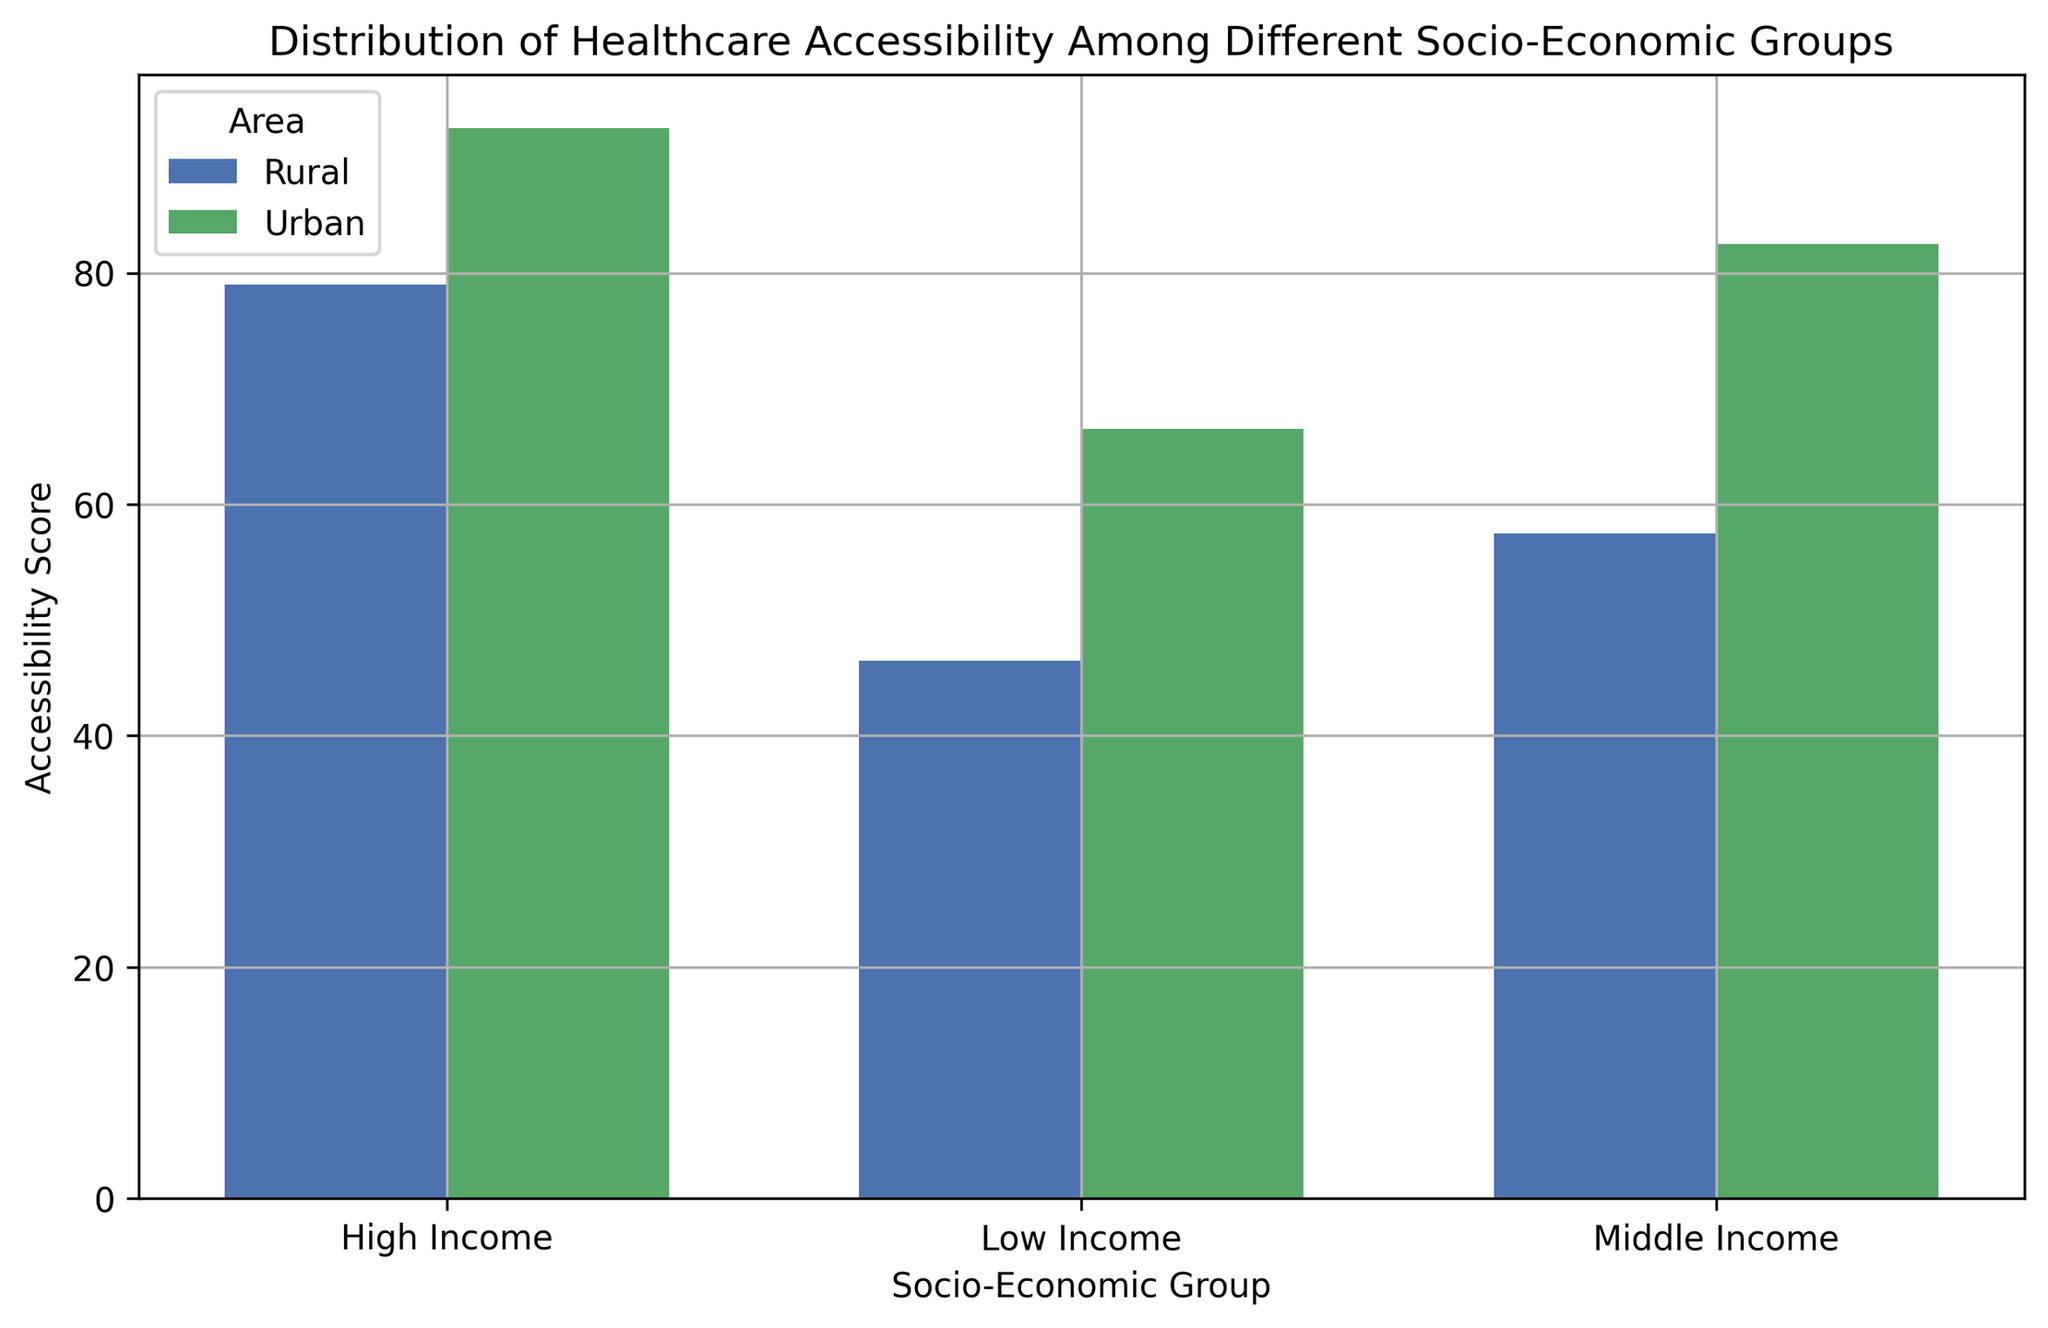Which socio-economic group has the highest accessibility score in urban areas? By comparing the bar heights for urban areas, we can see the tallest bar represents the High Income group. Thus, the High Income group has the highest accessibility score in urban areas.
Answer: High Income How much higher is the average healthcare accessibility score for High Income groups in urban areas than in rural areas? From the bar chart, the average accessibility scores for High Income groups are approximately 92.5 in urban areas and 79 in rural areas. Subtracting these, we get 92.5 - 79 = 13.5.
Answer: 13.5 Which area (urban or rural) shows a larger difference in accessibility scores between Low Income and High Income groups? Looking at the bars, the difference in scores between Low Income and High Income groups in urban areas appears to be about 92.5 - 66.5 = 26, while in rural areas, it is around 79 - 46.5 = 32.5. Rural areas show a larger difference.
Answer: Rural What is the average accessibility score for Middle Income groups across both areas? The average accessibility scores for Middle Income groups are approximately 82.5 for urban areas and 57.5 for rural areas. The overall average is (82.5 + 57.5) / 2 = 70.
Answer: 70 Does the Middle Income group have a higher accessibility score in urban areas compared to the High Income group in rural areas? The Middle Income group's score in urban areas is around 82.5, whereas the High Income group's score in rural areas is about 79. Comparing 82.5 and 79, we see that 82.5 > 79.
Answer: Yes Which socio-economic group has the least variation in accessibility scores between urban and rural areas? By comparing differences in bar heights between urban and rural areas, the Low Income group's scores are closest (65 in urban vs. 46.5 in rural), showing the least variation.
Answer: Low Income How do accessibility scores for Low Income groups in rural areas compare with Middle Income groups in the same area? In rural areas, the average score for Low Income groups is around 46.5, while for Middle Income groups, it is approximately 57.5. Comparing these, we see 46.5 < 57.5.
Answer: Lower What is the difference between the highest and lowest accessibility scores in urban areas? The highest score in urban areas is around 92.5 (High Income) and the lowest is about 65 (Low Income). The difference is 92.5 - 65 = 27.5.
Answer: 27.5 What can be inferred about healthcare accessibility in rural areas from the chart? From the bar heights, we can infer that healthcare accessibility scores generally increase with socio-economic status in rural areas, but they are consistently lower than their urban counterparts.
Answer: Generally lower 